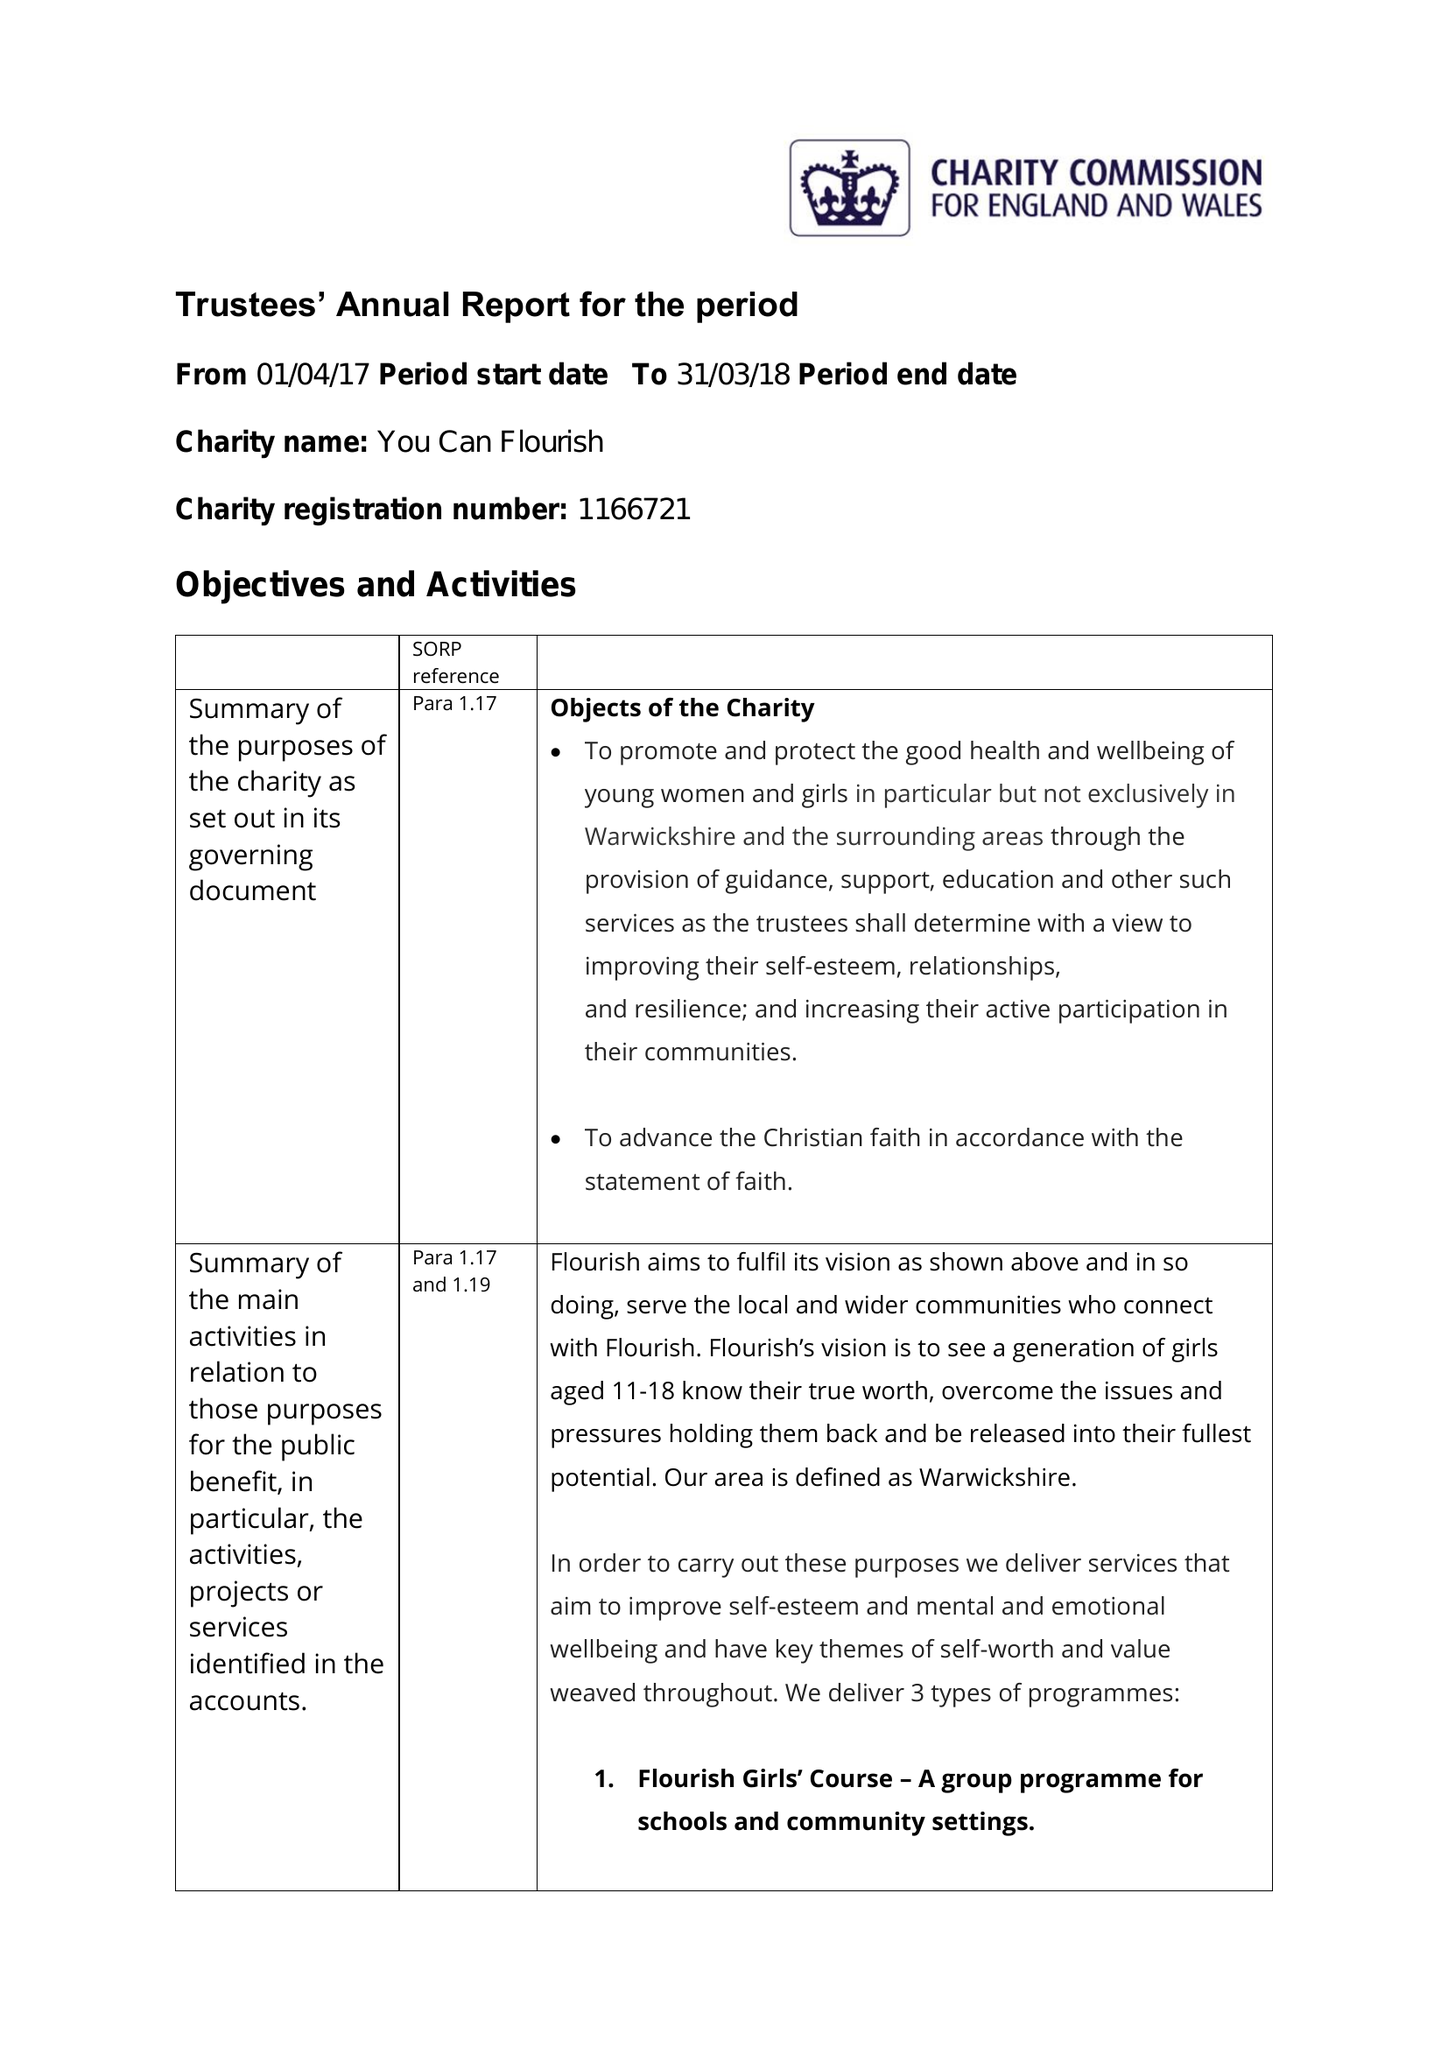What is the value for the address__post_town?
Answer the question using a single word or phrase. LEAMINGTON SPA 